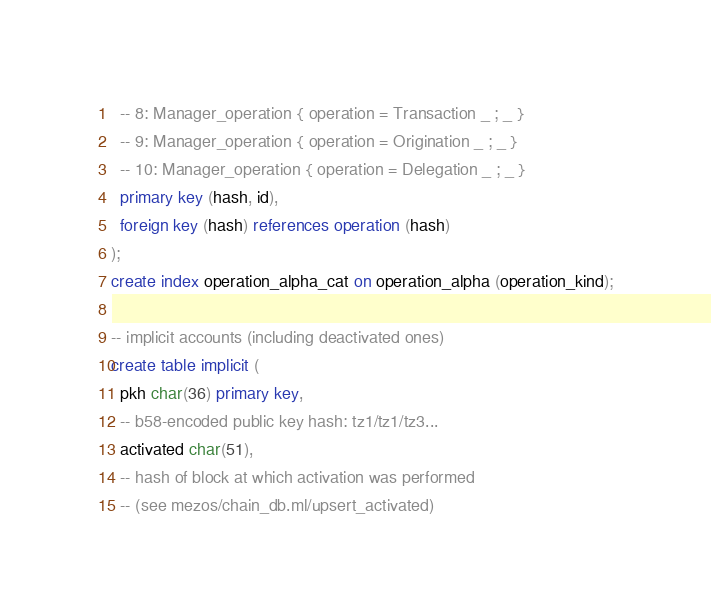<code> <loc_0><loc_0><loc_500><loc_500><_SQL_>  -- 8: Manager_operation { operation = Transaction _ ; _ }
  -- 9: Manager_operation { operation = Origination _ ; _ }
  -- 10: Manager_operation { operation = Delegation _ ; _ }
  primary key (hash, id),
  foreign key (hash) references operation (hash)
);
create index operation_alpha_cat on operation_alpha (operation_kind);

-- implicit accounts (including deactivated ones)
create table implicit (
  pkh char(36) primary key,
  -- b58-encoded public key hash: tz1/tz1/tz3...
  activated char(51),
  -- hash of block at which activation was performed
  -- (see mezos/chain_db.ml/upsert_activated)</code> 